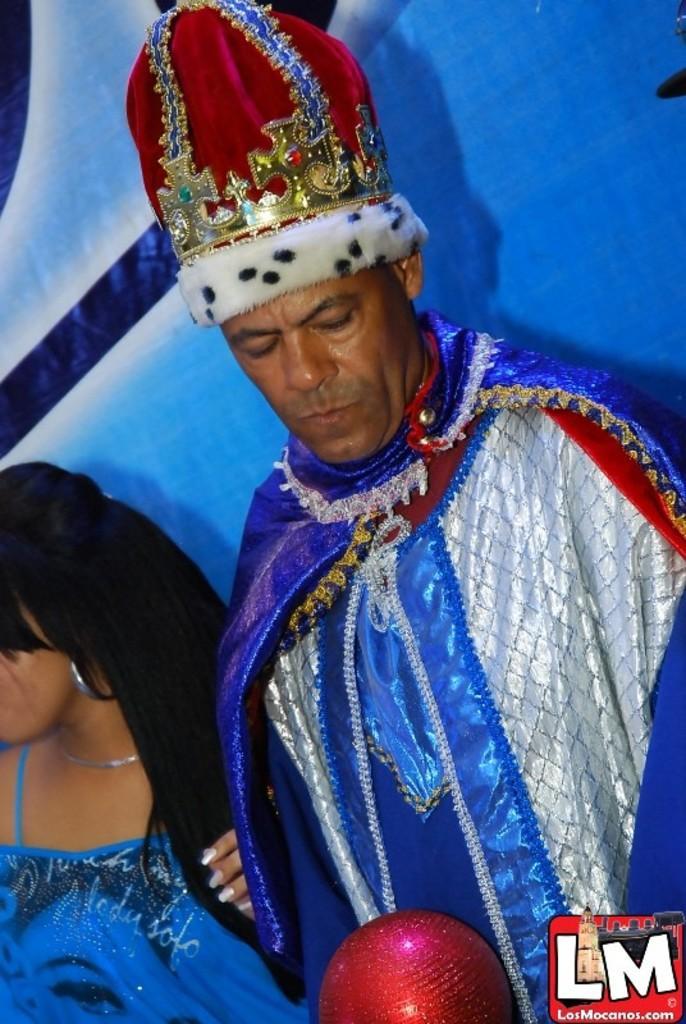Could you give a brief overview of what you see in this image? In this image we can see there is a person and a lady standing. In the background there is a banner. 